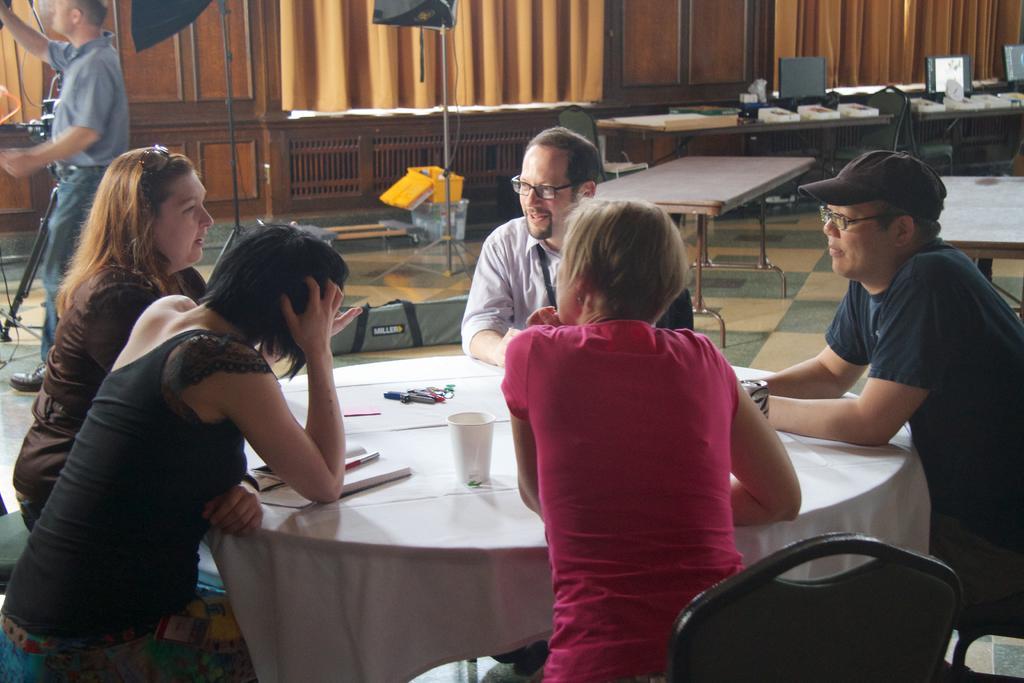In one or two sentences, can you explain what this image depicts? In this picture there are a group of people sitting near the table and talking with each other. 